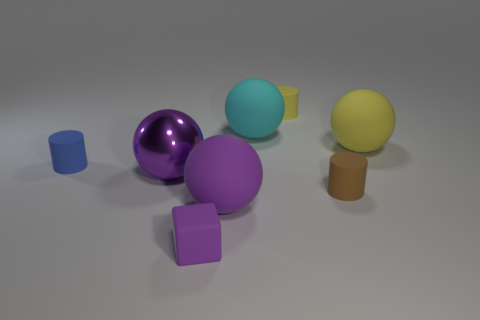Subtract all matte spheres. How many spheres are left? 1 Subtract all yellow balls. How many balls are left? 3 Add 1 big purple matte spheres. How many objects exist? 9 Subtract all brown spheres. Subtract all green blocks. How many spheres are left? 4 Add 2 red cylinders. How many red cylinders exist? 2 Subtract 0 green cylinders. How many objects are left? 8 Subtract all blocks. How many objects are left? 7 Subtract all blue rubber objects. Subtract all tiny blue rubber objects. How many objects are left? 6 Add 7 big rubber things. How many big rubber things are left? 10 